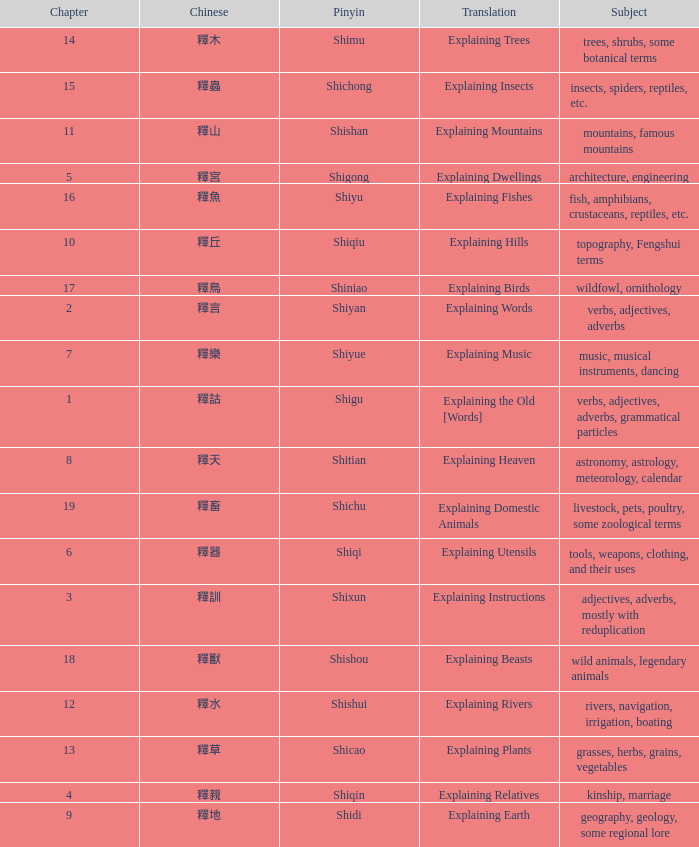Name the total number of chapter for chinese of 釋宮 1.0. 